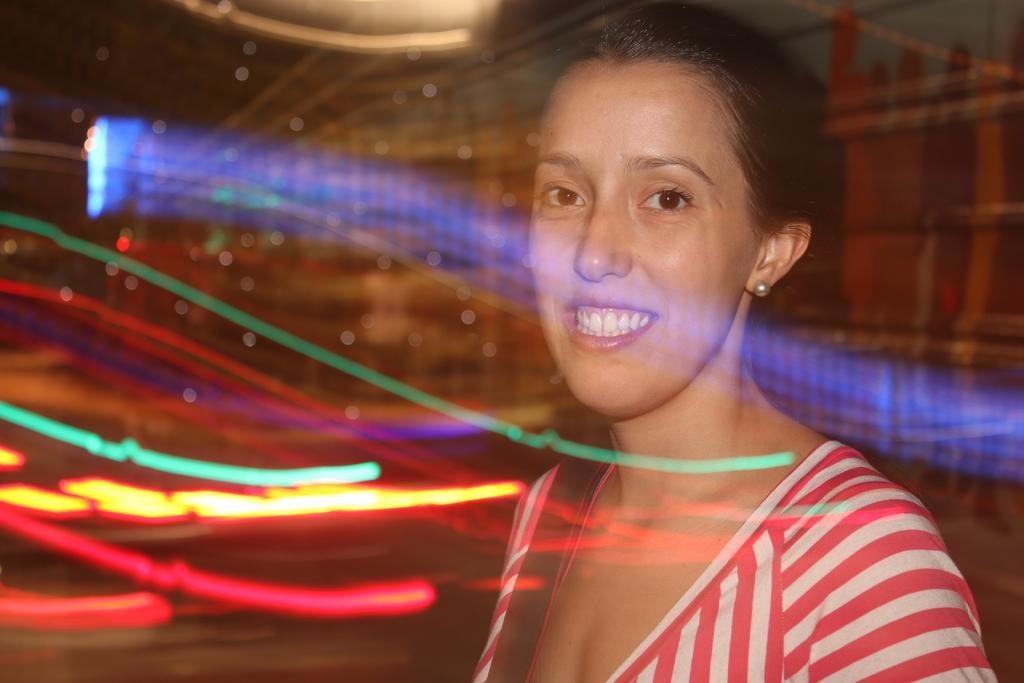Can you describe this image briefly? In this image, we can see a person wearing clothes on the colorful background. 